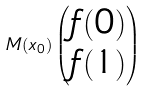Convert formula to latex. <formula><loc_0><loc_0><loc_500><loc_500>M ( x _ { 0 } ) \begin{pmatrix} f ( 0 ) \\ f ( 1 ) \end{pmatrix}</formula> 